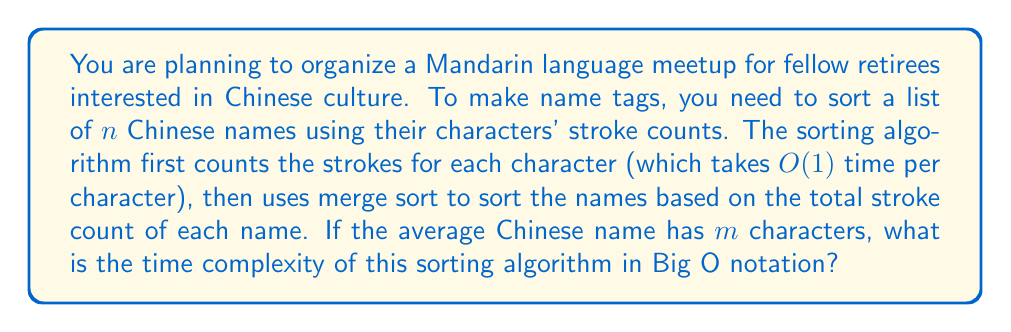Could you help me with this problem? Let's break down the problem and analyze it step by step:

1) Counting strokes:
   - For each name, we need to count the strokes of each character.
   - There are $n$ names, and each name has an average of $m$ characters.
   - Counting strokes for one character takes $O(1)$ time.
   - So, the total time for counting strokes is $O(n \cdot m)$.

2) Merge sort:
   - After counting strokes, we have $n$ names to sort.
   - Merge sort has a time complexity of $O(n \log n)$.

3) Combining the steps:
   - The total time complexity is the sum of the stroke counting and sorting steps.
   - This gives us: $O(n \cdot m + n \log n)$

4) Simplifying:
   - In Big O notation, we keep the term that grows the fastest.
   - $n \cdot m$ grows faster than $n \log n$ when $m > \log n$.
   - However, since $m$ is the average number of characters in a name, it's typically small and constant.
   - Therefore, we can consider $m$ as a constant factor.

5) Final analysis:
   - With $m$ as a constant, $n \cdot m$ becomes $O(n)$.
   - The dominant term is now $n \log n$.

Thus, the overall time complexity of the algorithm is $O(n \log n)$.
Answer: $O(n \log n)$ 